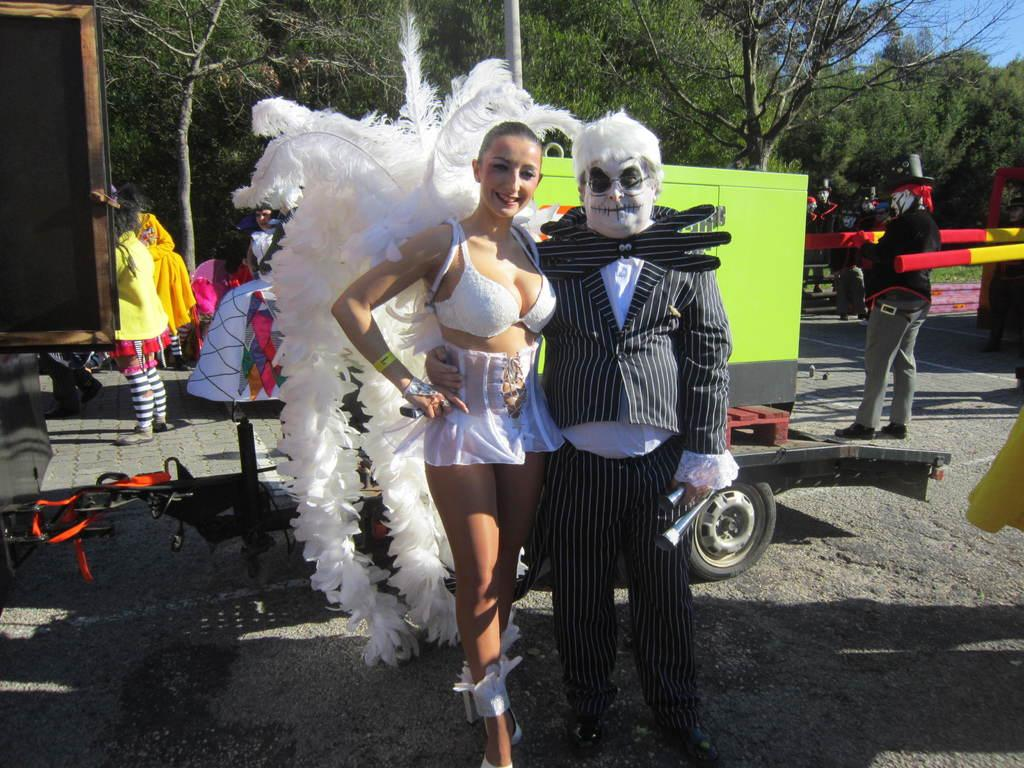How many people are in the center of the image? There are two people, a man and a woman, in the center of the image. What are the man and woman wearing in the image? The man and woman are wearing costumes in the image. What can be seen in the background of the image? There are other people, vehicles, and trees in the background of the image. How many giants are present in the image? There are no giants present in the image; it features a man and a woman wearing costumes. What type of queen can be seen in the image? There is no queen present in the image; it features a man and a woman wearing costumes. 